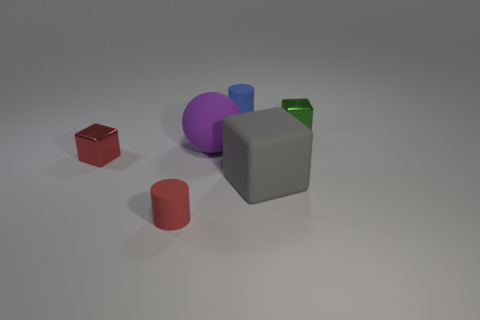Add 2 small red spheres. How many objects exist? 8 Subtract all cylinders. How many objects are left? 4 Add 4 small purple matte blocks. How many small purple matte blocks exist? 4 Subtract 0 cyan balls. How many objects are left? 6 Subtract all red objects. Subtract all purple balls. How many objects are left? 3 Add 4 purple matte things. How many purple matte things are left? 5 